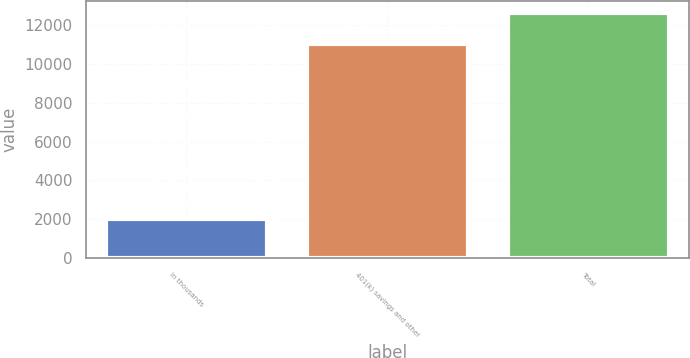Convert chart to OTSL. <chart><loc_0><loc_0><loc_500><loc_500><bar_chart><fcel>In thousands<fcel>401(k) savings and other<fcel>Total<nl><fcel>2011<fcel>11045<fcel>12619<nl></chart> 